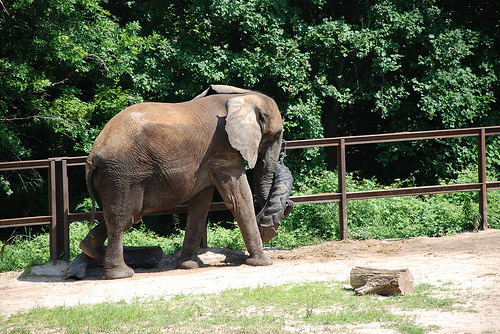<image>
Is the dirt to the right of the animal? No. The dirt is not to the right of the animal. The horizontal positioning shows a different relationship. 